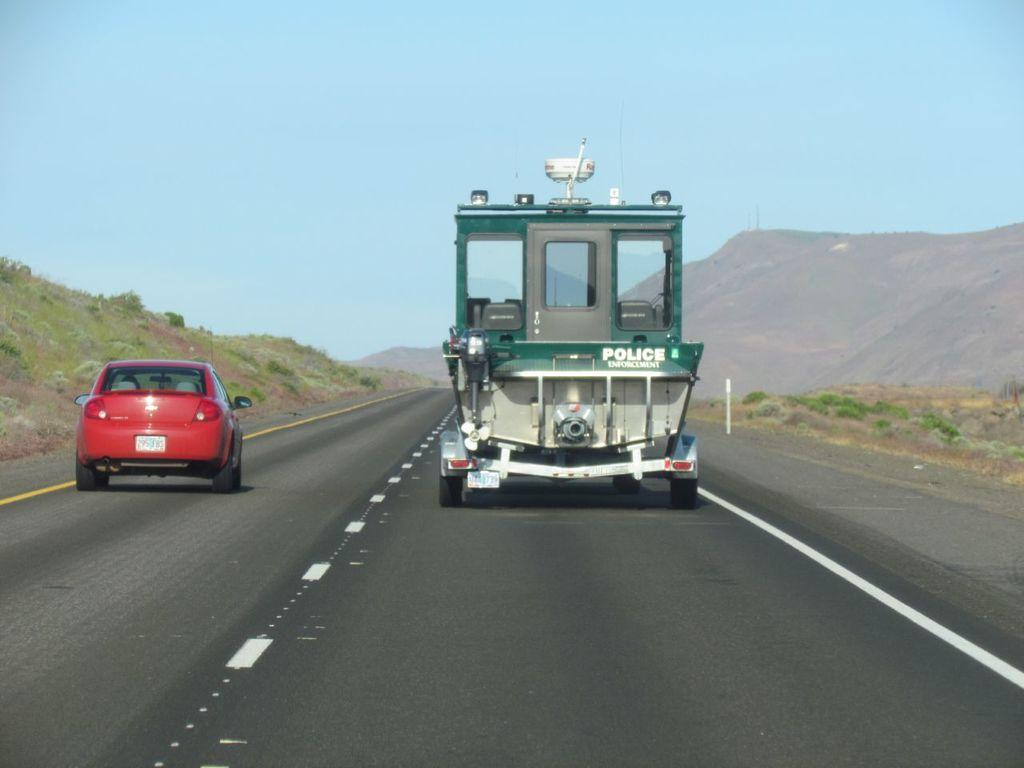What is the main subject of the image? There is a car in the image. Can you describe the car's appearance? The car is red. What else can be seen on the road in the image? There is another vehicle moving on the road. What type of vegetation is visible in the image? There are plants visible in the image. How would you describe the sky in the image? The sky is blue and cloudy. What geographical feature can be seen in the image? There is a hill in the image. Where is the store located in the image? There is no store present in the image. What type of shake can be seen in the image? There is no shake present in the image. 